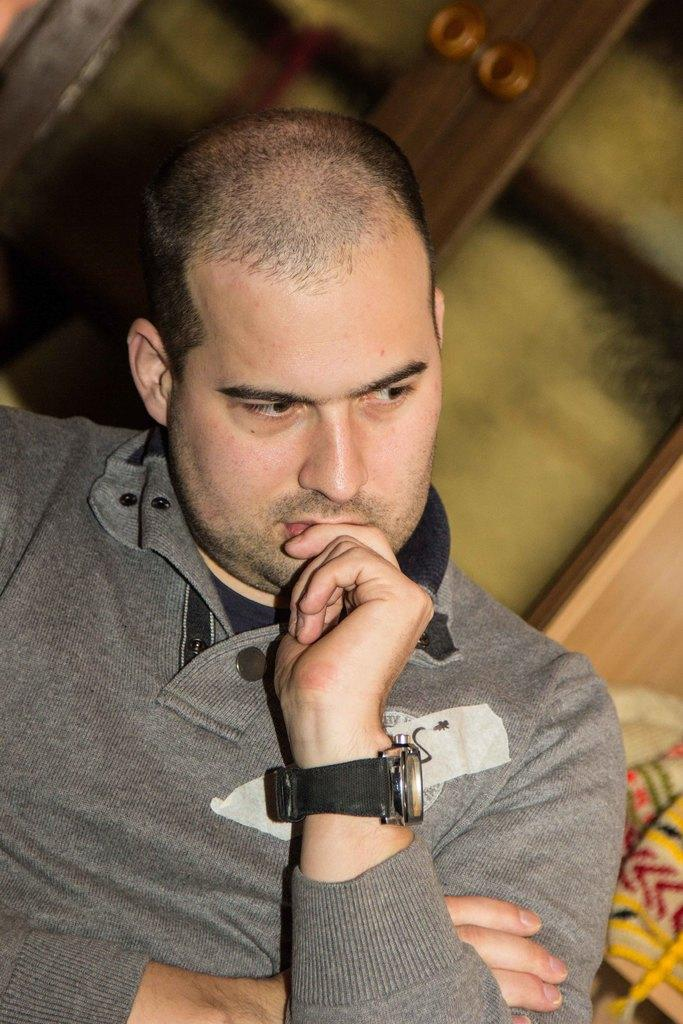What is the person in the image doing? The person is sitting in the image. What is the person wearing on their upper body? The person is wearing a grey t-shirt. Does the person have any accessories visible in the image? Yes, the person is wearing a watch. What type of shop can be seen in the background of the image? There is no shop visible in the background of the image. How does the person in the image express disgust? The image does not show any expression of disgust from the person. 